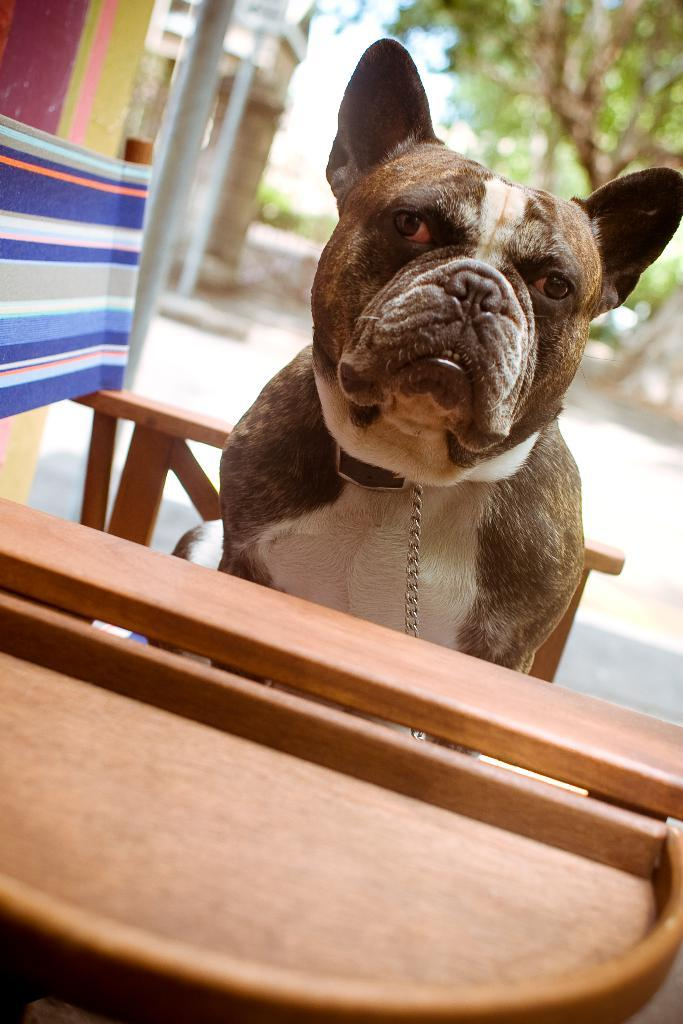What is the dog doing in the image? The dog is sitting on a chair in the image. What other piece of furniture is present in the image? There is a table in the image. What can be seen in the background of the image? Trees and the sky are visible in the background of the image. What type of industry can be seen in the aftermath of the dog's actions in the image? There is no industry or aftermath of any actions present in the image; it simply shows a dog sitting on a chair with a table and a background of trees and sky. 